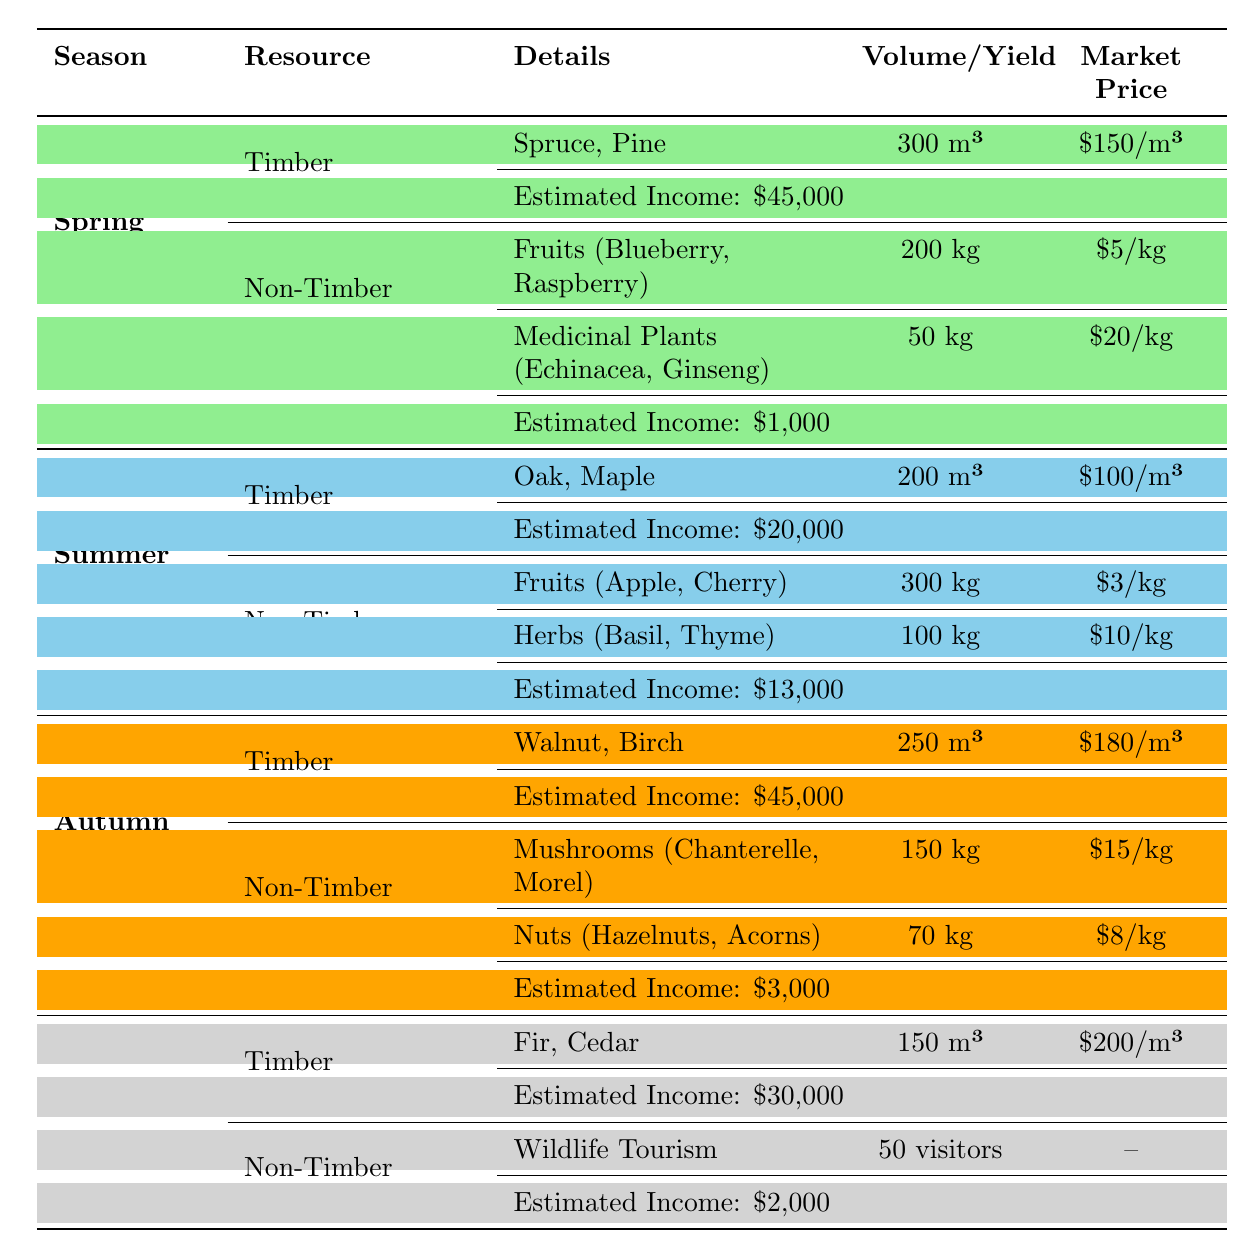What is the total estimated income from timber sales in Spring? In Spring, the estimated income from timber sales is directly listed in the table under "ImpactOnLoggingIncome." It states that the income from timber sales is $45,000. Therefore, the total estimated income from timber sales in Spring is $45,000.
Answer: $45,000 How many kilograms of herbs are available in Summer? In Summer, under the Non-Timber section, the table provides the yield of herbs, specifically listed as "Basil, Thyme." The yield is stated as 100 kg. Therefore, the total kilograms of herbs available in Summer is 100 kg.
Answer: 100 kg True or False: The market price per cubic meter of timber is highest in Winter. The table shows the market prices for timber across the seasons: Spring is $150/m³, Summer is $100/m³, Autumn is $180/m³, and Winter is $200/m³. Since Winter has the highest price at $200/m³, the statement is true.
Answer: True What is the total estimated income from non-timber products in Autumn and Summer combined? The estimated income from non-timber products in Autumn is $3,000 and in Summer is $13,000. To find the combined income, add these two amounts: $3,000 (Autumn) + $13,000 (Summer) = $16,000. Therefore, the total estimated income from non-timber products in Autumn and Summer combined is $16,000.
Answer: $16,000 Which season has the highest yield of fruits? In Summer, the yield of fruits (Apple, Cherry) is 300 kg, which is higher than the yield of fruits in Spring (200 kg) and the lack of specified non-timber fruit yield in Autumn and Winter. Thus, Summer has the highest yield of fruits at 300 kg.
Answer: Summer 